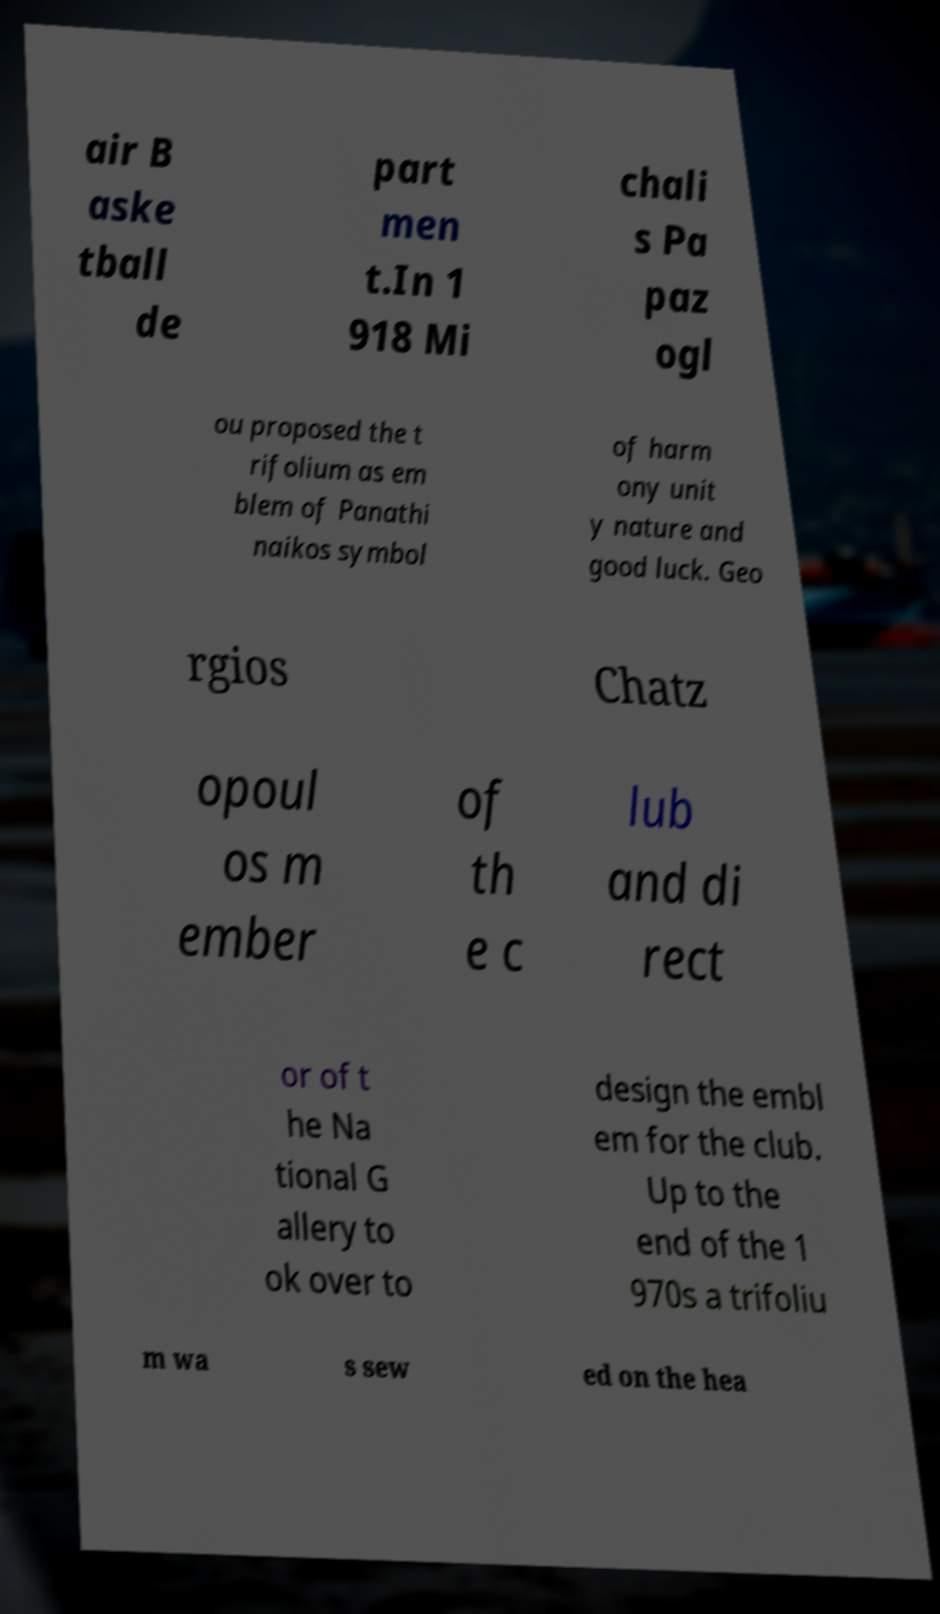What messages or text are displayed in this image? I need them in a readable, typed format. air B aske tball de part men t.In 1 918 Mi chali s Pa paz ogl ou proposed the t rifolium as em blem of Panathi naikos symbol of harm ony unit y nature and good luck. Geo rgios Chatz opoul os m ember of th e c lub and di rect or of t he Na tional G allery to ok over to design the embl em for the club. Up to the end of the 1 970s a trifoliu m wa s sew ed on the hea 